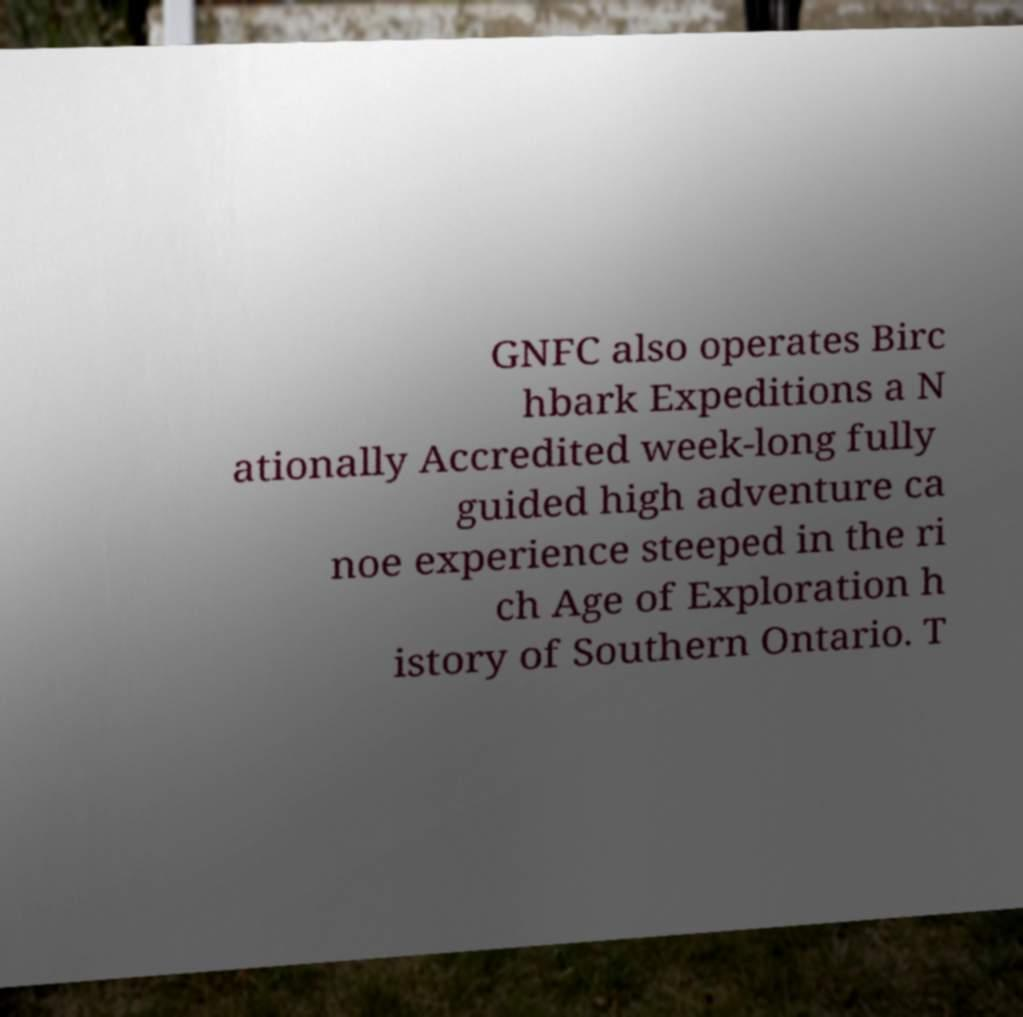Can you read and provide the text displayed in the image?This photo seems to have some interesting text. Can you extract and type it out for me? GNFC also operates Birc hbark Expeditions a N ationally Accredited week-long fully guided high adventure ca noe experience steeped in the ri ch Age of Exploration h istory of Southern Ontario. T 